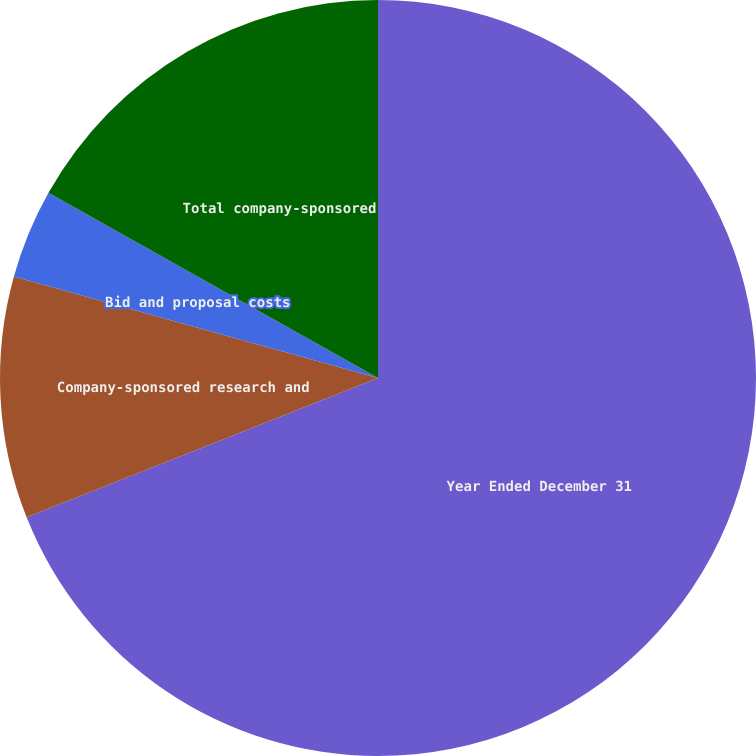<chart> <loc_0><loc_0><loc_500><loc_500><pie_chart><fcel>Year Ended December 31<fcel>Company-sponsored research and<fcel>Bid and proposal costs<fcel>Total company-sponsored<nl><fcel>68.99%<fcel>10.34%<fcel>3.82%<fcel>16.85%<nl></chart> 